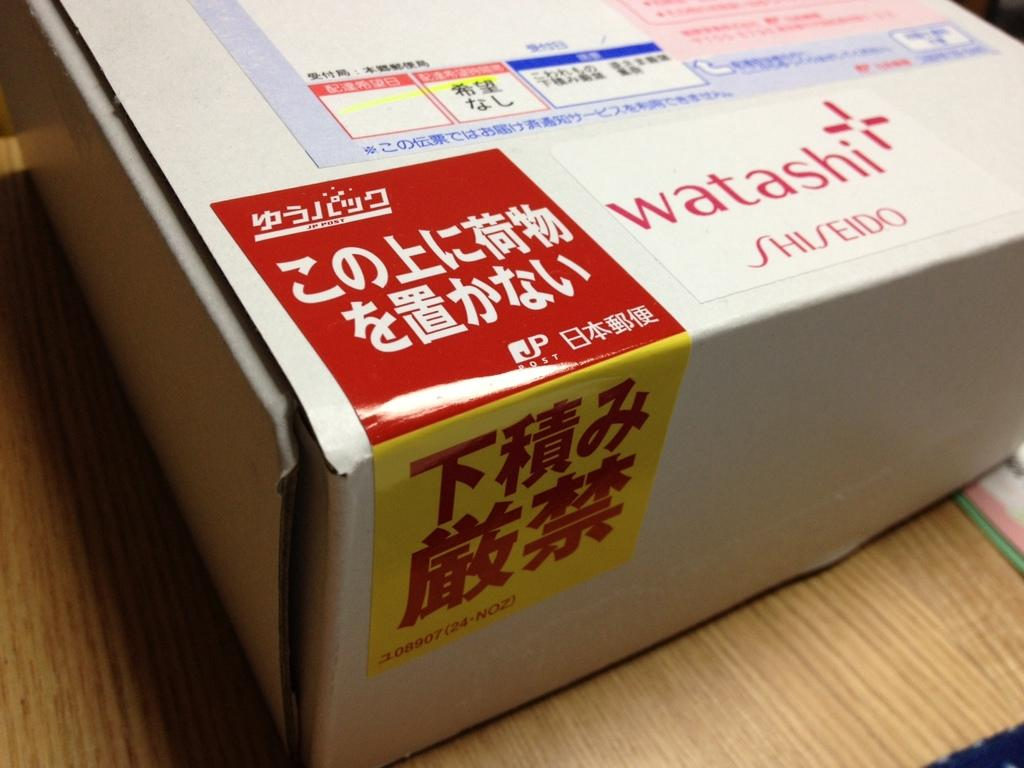Provide a one-sentence caption for the provided image. A box of goods from Watashi Shiseido with the rest of the text written in Japanese. 